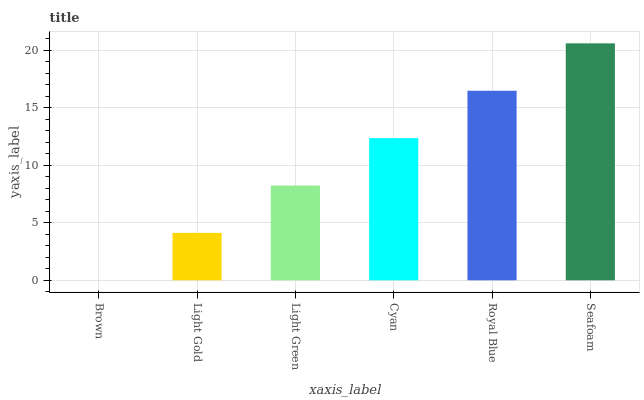Is Brown the minimum?
Answer yes or no. Yes. Is Seafoam the maximum?
Answer yes or no. Yes. Is Light Gold the minimum?
Answer yes or no. No. Is Light Gold the maximum?
Answer yes or no. No. Is Light Gold greater than Brown?
Answer yes or no. Yes. Is Brown less than Light Gold?
Answer yes or no. Yes. Is Brown greater than Light Gold?
Answer yes or no. No. Is Light Gold less than Brown?
Answer yes or no. No. Is Cyan the high median?
Answer yes or no. Yes. Is Light Green the low median?
Answer yes or no. Yes. Is Seafoam the high median?
Answer yes or no. No. Is Light Gold the low median?
Answer yes or no. No. 